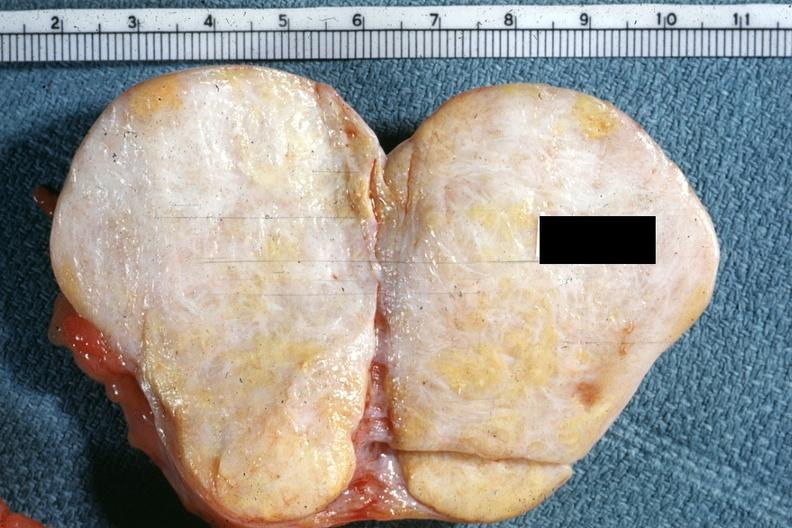what is no ovary present to indicate the location of the tumor mass?
Answer the question using a single word or phrase. There 